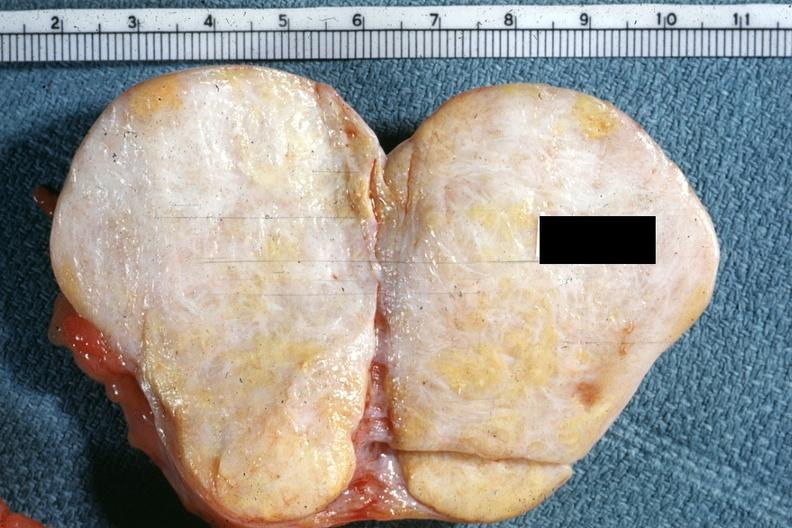what is no ovary present to indicate the location of the tumor mass?
Answer the question using a single word or phrase. There 